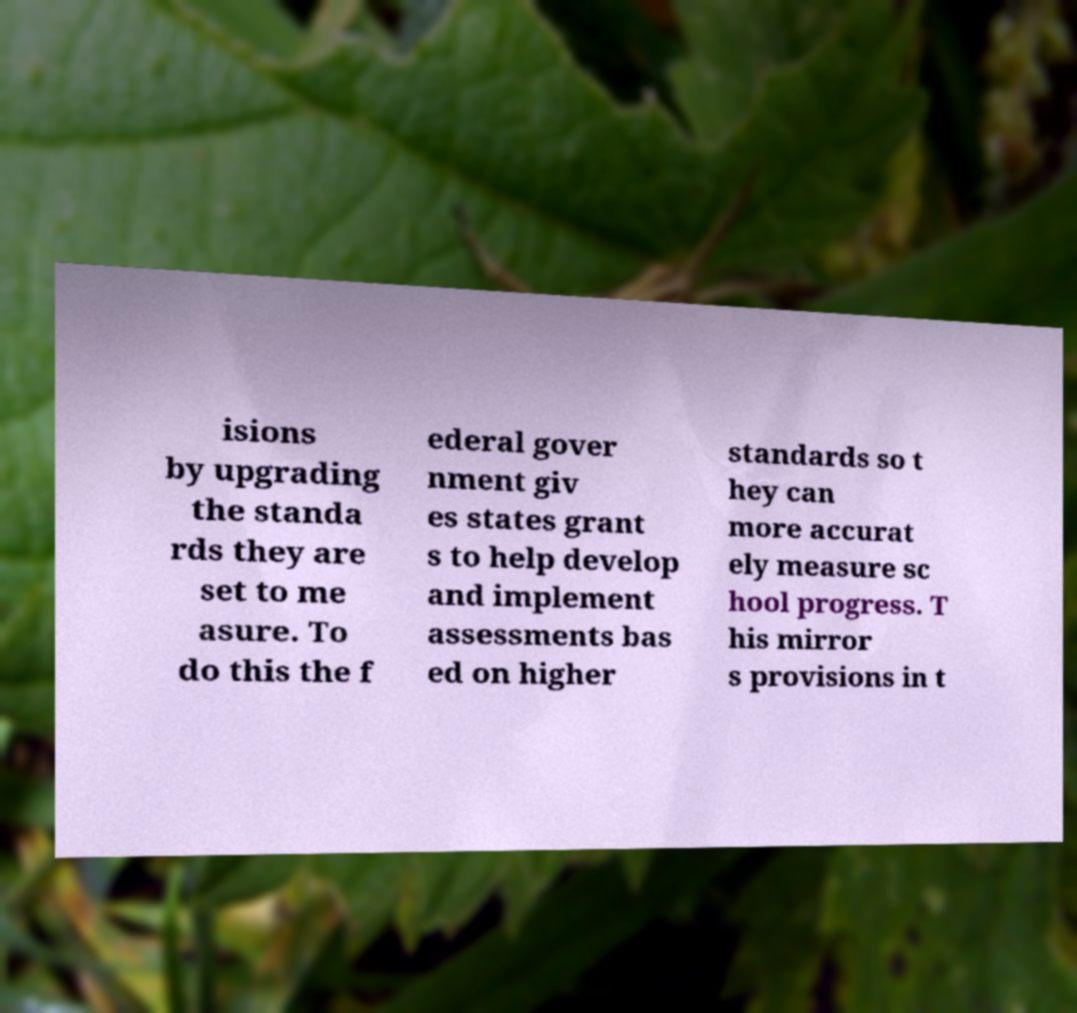Can you read and provide the text displayed in the image?This photo seems to have some interesting text. Can you extract and type it out for me? isions by upgrading the standa rds they are set to me asure. To do this the f ederal gover nment giv es states grant s to help develop and implement assessments bas ed on higher standards so t hey can more accurat ely measure sc hool progress. T his mirror s provisions in t 